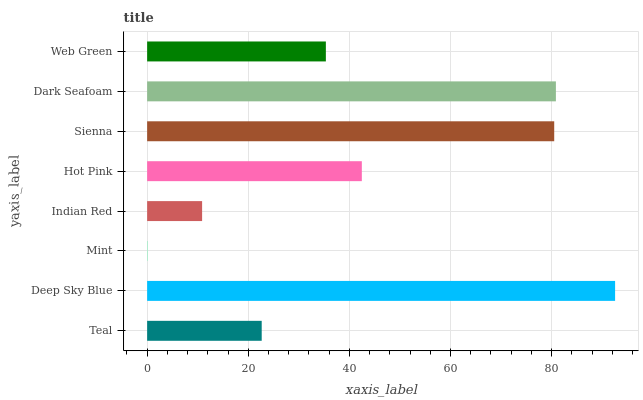Is Mint the minimum?
Answer yes or no. Yes. Is Deep Sky Blue the maximum?
Answer yes or no. Yes. Is Deep Sky Blue the minimum?
Answer yes or no. No. Is Mint the maximum?
Answer yes or no. No. Is Deep Sky Blue greater than Mint?
Answer yes or no. Yes. Is Mint less than Deep Sky Blue?
Answer yes or no. Yes. Is Mint greater than Deep Sky Blue?
Answer yes or no. No. Is Deep Sky Blue less than Mint?
Answer yes or no. No. Is Hot Pink the high median?
Answer yes or no. Yes. Is Web Green the low median?
Answer yes or no. Yes. Is Teal the high median?
Answer yes or no. No. Is Teal the low median?
Answer yes or no. No. 